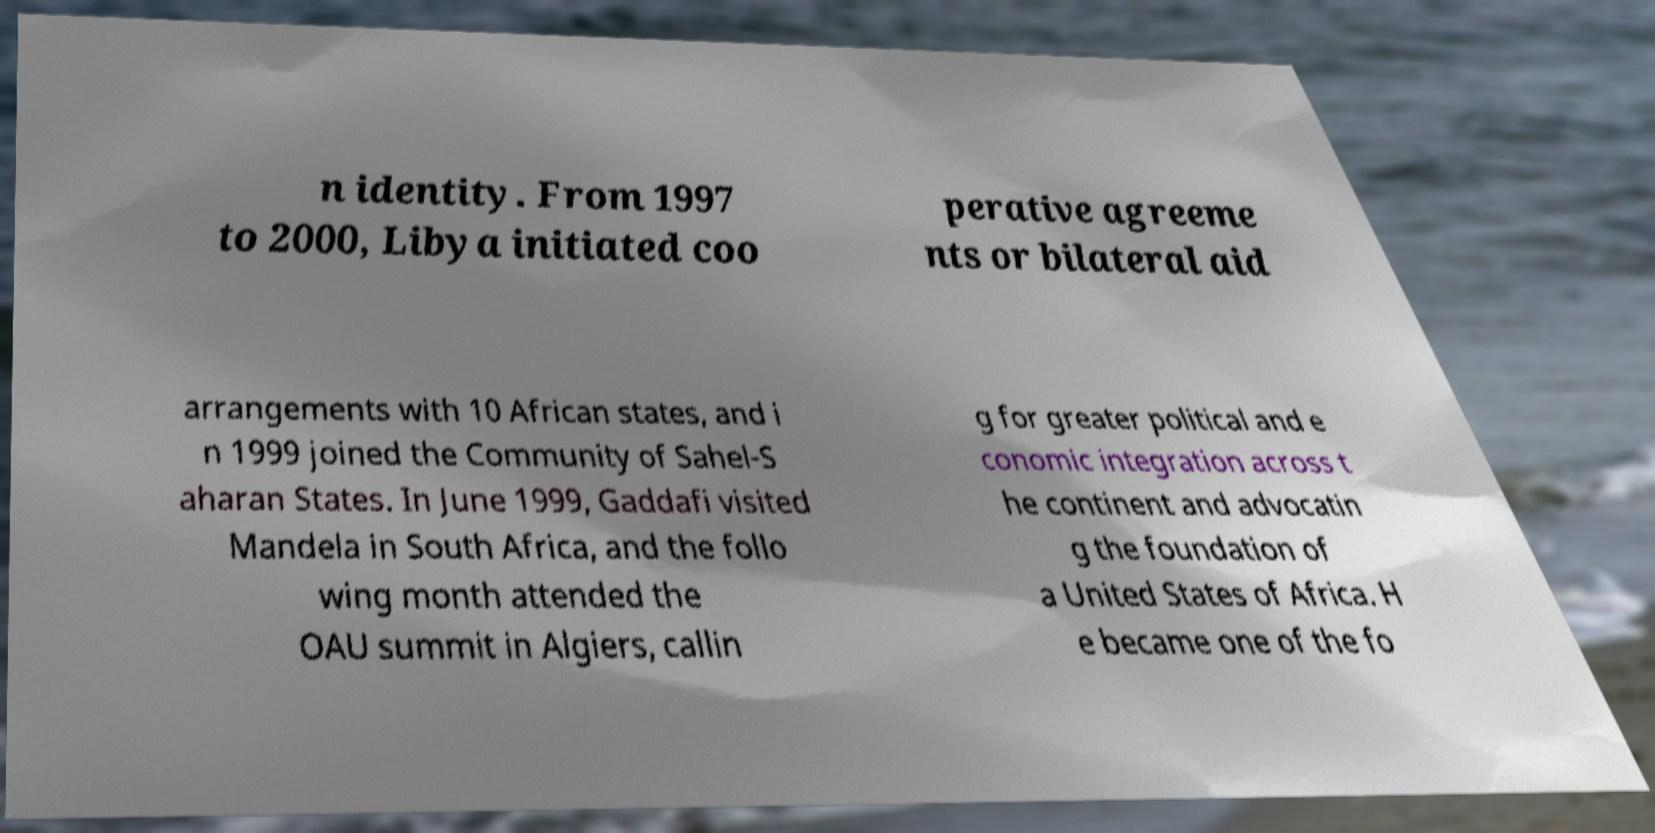Could you assist in decoding the text presented in this image and type it out clearly? n identity. From 1997 to 2000, Libya initiated coo perative agreeme nts or bilateral aid arrangements with 10 African states, and i n 1999 joined the Community of Sahel-S aharan States. In June 1999, Gaddafi visited Mandela in South Africa, and the follo wing month attended the OAU summit in Algiers, callin g for greater political and e conomic integration across t he continent and advocatin g the foundation of a United States of Africa. H e became one of the fo 